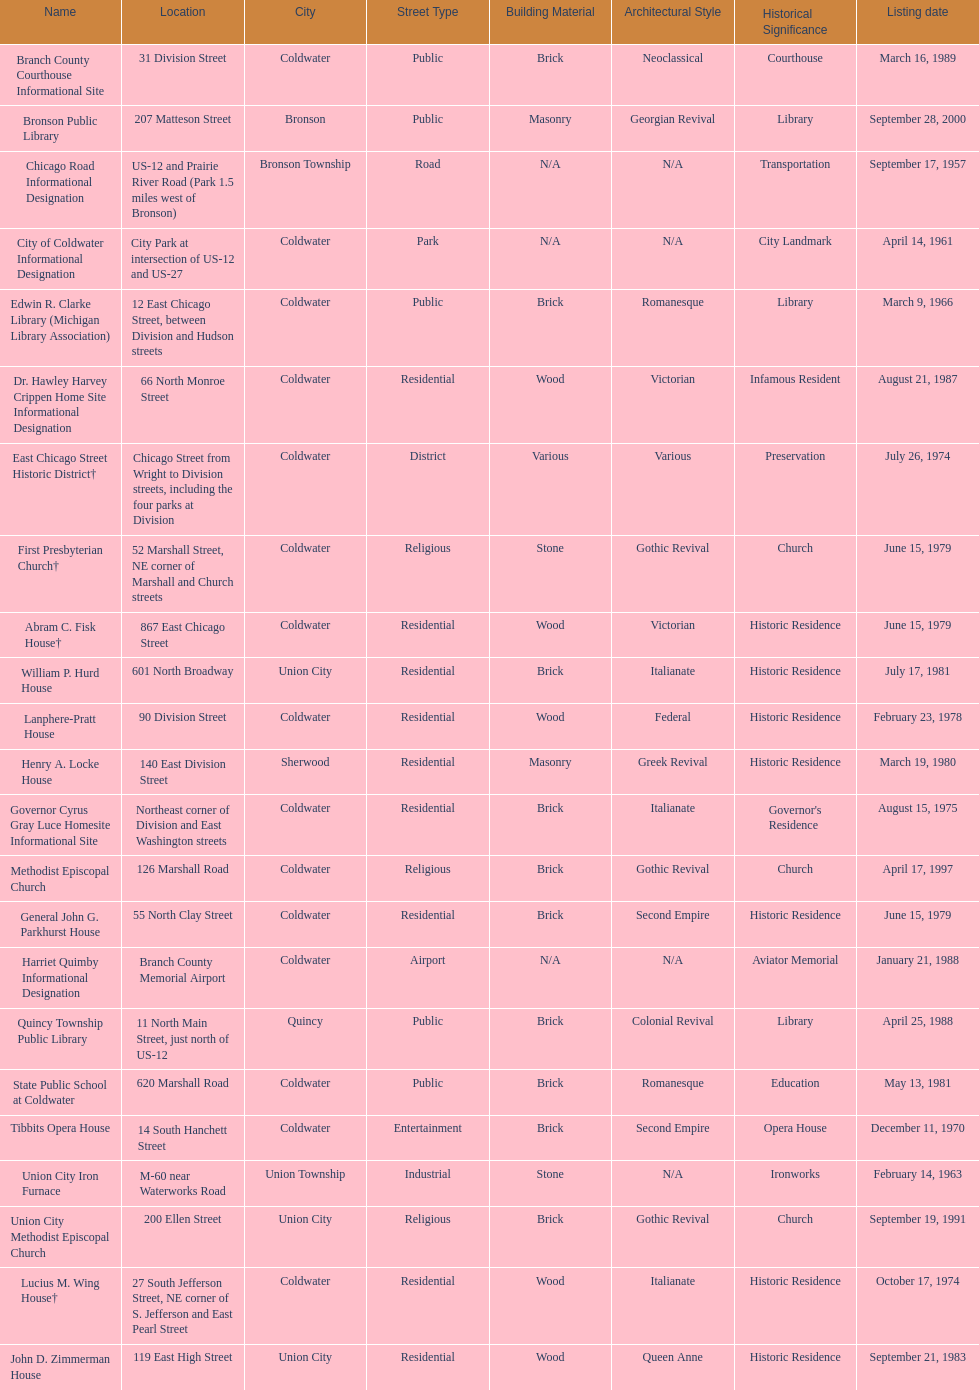What is the total current listing of names on this chart? 23. 